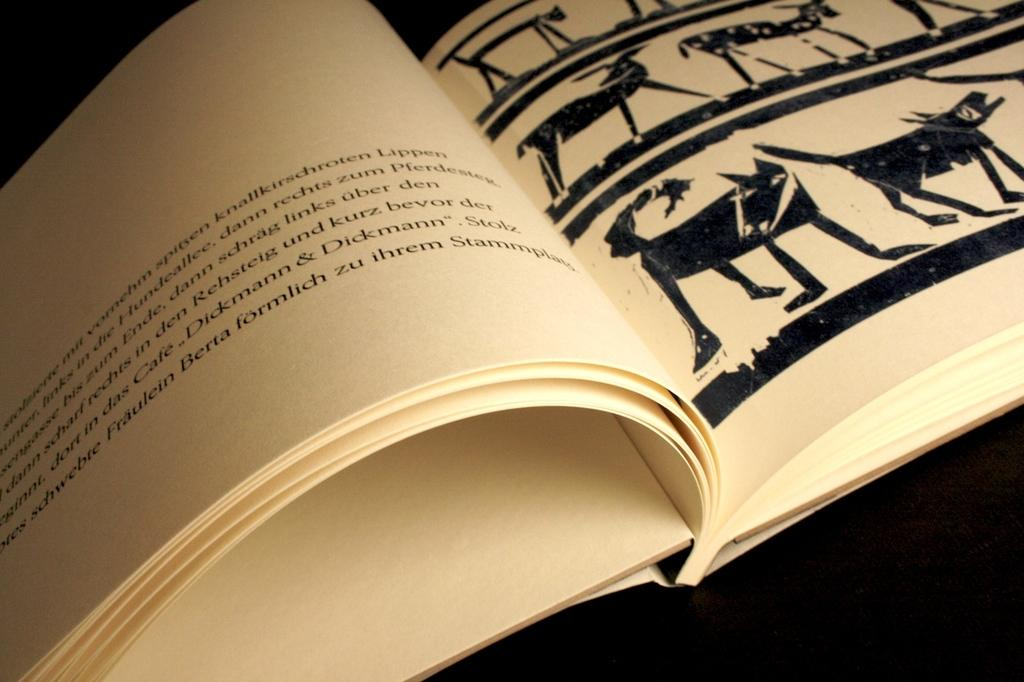What is the main object in the image? There is a book in the image. What can be found on the pages of the book? The papers in the book contain text and images of animals. What color is the background of the image? The background of the image is black. How many masks are visible in the image? There are no masks present in the image. What type of tail is shown on the animals in the image? There are no tails visible in the image, as the images of animals are not detailed enough to show specific body parts. 